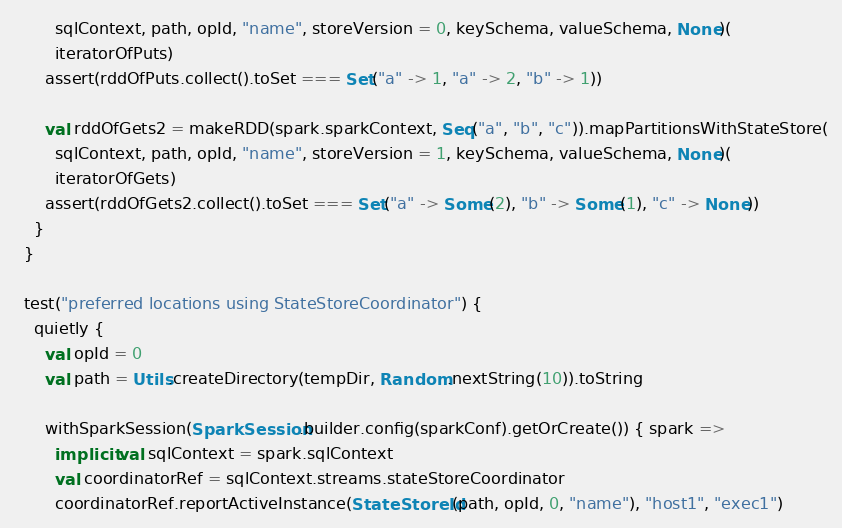Convert code to text. <code><loc_0><loc_0><loc_500><loc_500><_Scala_>        sqlContext, path, opId, "name", storeVersion = 0, keySchema, valueSchema, None)(
        iteratorOfPuts)
      assert(rddOfPuts.collect().toSet === Set("a" -> 1, "a" -> 2, "b" -> 1))

      val rddOfGets2 = makeRDD(spark.sparkContext, Seq("a", "b", "c")).mapPartitionsWithStateStore(
        sqlContext, path, opId, "name", storeVersion = 1, keySchema, valueSchema, None)(
        iteratorOfGets)
      assert(rddOfGets2.collect().toSet === Set("a" -> Some(2), "b" -> Some(1), "c" -> None))
    }
  }

  test("preferred locations using StateStoreCoordinator") {
    quietly {
      val opId = 0
      val path = Utils.createDirectory(tempDir, Random.nextString(10)).toString

      withSparkSession(SparkSession.builder.config(sparkConf).getOrCreate()) { spark =>
        implicit val sqlContext = spark.sqlContext
        val coordinatorRef = sqlContext.streams.stateStoreCoordinator
        coordinatorRef.reportActiveInstance(StateStoreId(path, opId, 0, "name"), "host1", "exec1")</code> 